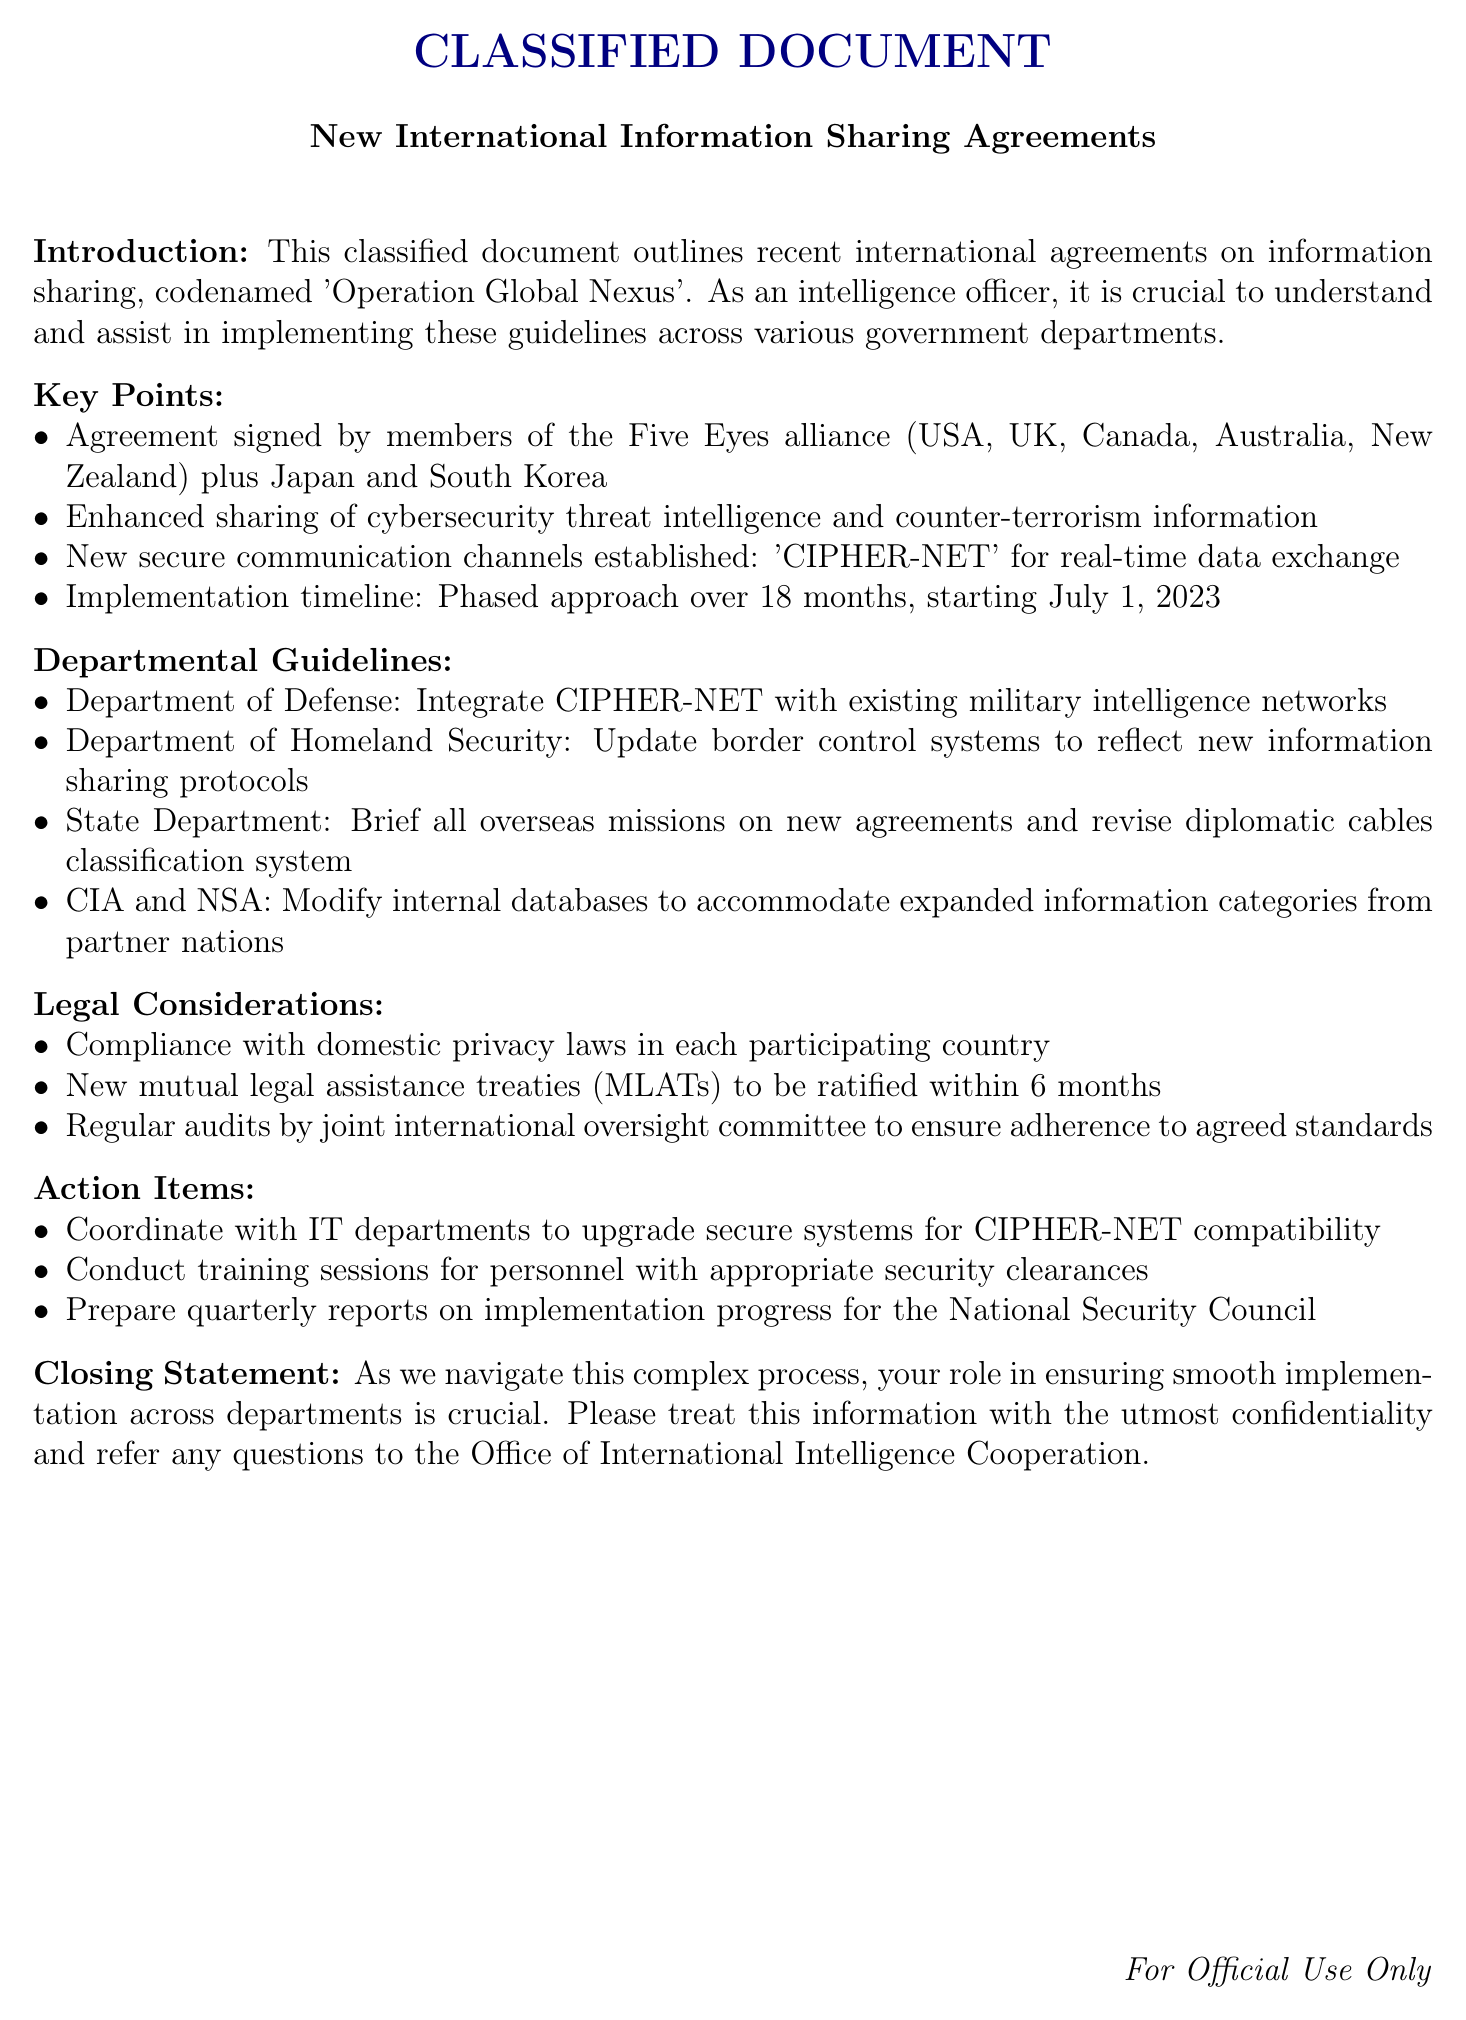What is the codename of the operation? The codename of the operation is mentioned in the introduction of the document.
Answer: Operation Global Nexus Which countries are part of the signed agreement? The document lists the countries involved in the agreement in the key points section.
Answer: USA, UK, Canada, Australia, New Zealand, Japan, South Korea What is the implementation timeline duration? The document specifies the duration of the implementation timeline in the key points section.
Answer: 18 months What secure communication channel has been established? The document explicitly states the name of the secure communication channel.
Answer: CIPHER-NET Which department is responsible for updating border control systems? The document outlines the departmental guidelines regarding responsibilities for different departments.
Answer: Department of Homeland Security What is required to be ratified within six months? The legal considerations section names the item that must be ratified.
Answer: New mutual legal assistance treaties (MLATs) How often should progress reports be prepared? The action items section indicates the frequency of report preparation.
Answer: Quarterly Who should treat the information with the utmost confidentiality? The closing statement addresses the audience's responsibility regarding the confidentiality of the information.
Answer: All personnel 